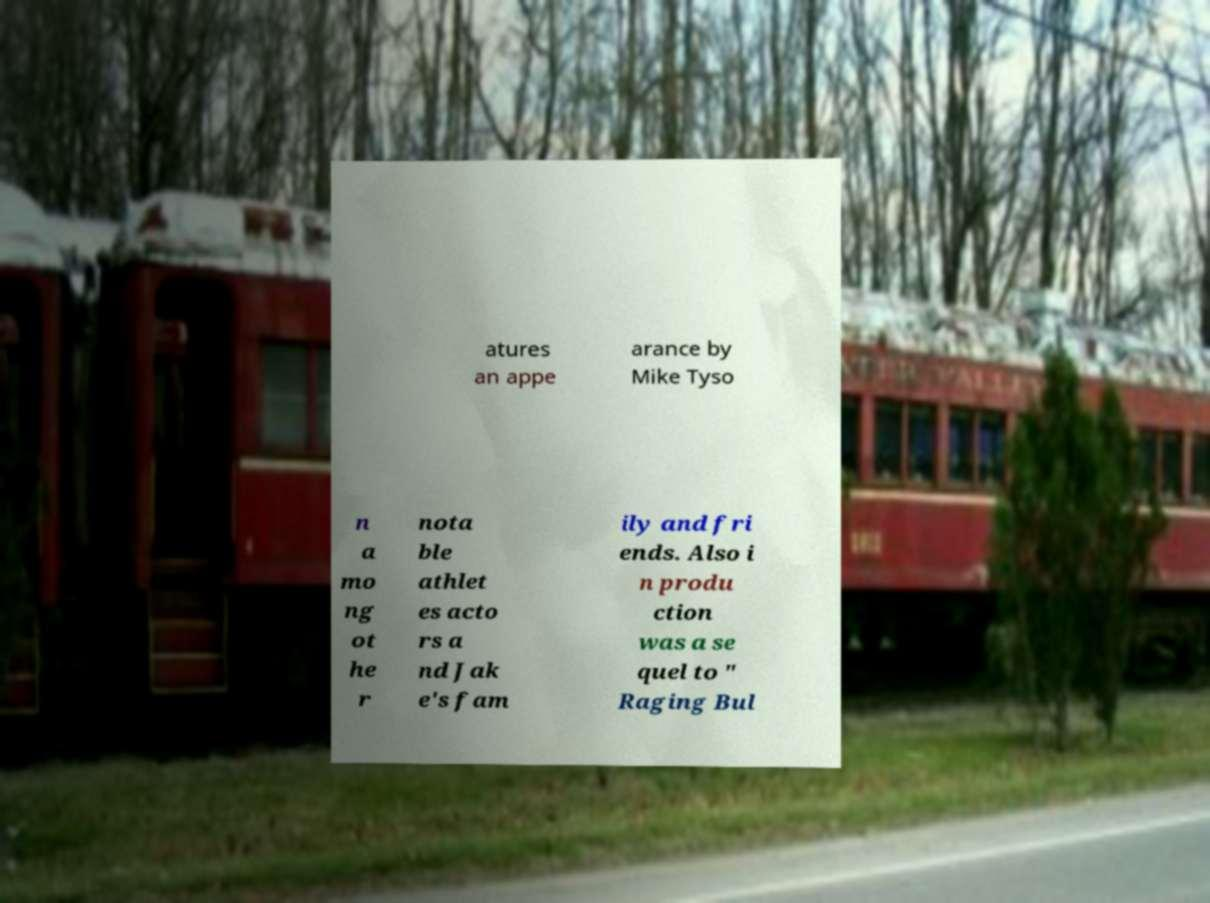I need the written content from this picture converted into text. Can you do that? atures an appe arance by Mike Tyso n a mo ng ot he r nota ble athlet es acto rs a nd Jak e's fam ily and fri ends. Also i n produ ction was a se quel to " Raging Bul 